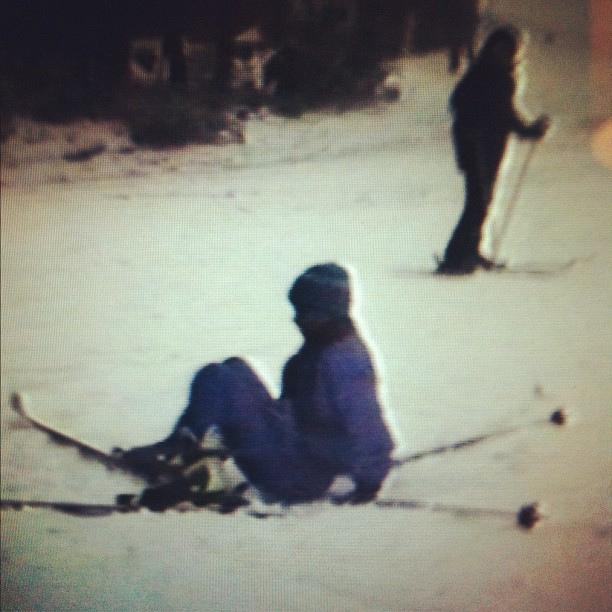Why is the ground white?
Keep it brief. Snow. Is the snow deep?
Give a very brief answer. No. Did the skier in the blue parka fall?
Quick response, please. Yes. 